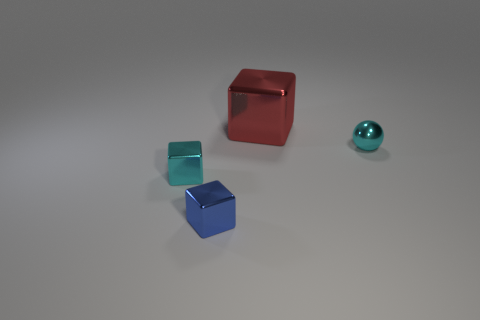There is a big shiny object; is its shape the same as the tiny cyan thing that is to the left of the large red block?
Offer a terse response. Yes. There is a small object that is the same color as the ball; what material is it?
Ensure brevity in your answer.  Metal. Is there any other thing that is the same shape as the big shiny object?
Offer a terse response. Yes. Do the cyan cube and the thing that is behind the tiny cyan metal sphere have the same material?
Keep it short and to the point. Yes. What is the color of the block that is in front of the cyan object left of the small thing that is right of the red shiny thing?
Ensure brevity in your answer.  Blue. Is there anything else that is the same size as the red thing?
Provide a short and direct response. No. Do the shiny ball and the block that is behind the cyan sphere have the same color?
Your answer should be compact. No. The small metallic ball is what color?
Keep it short and to the point. Cyan. The tiny shiny object right of the tiny cube right of the small cyan object that is on the left side of the red shiny object is what shape?
Make the answer very short. Sphere. How many other objects are the same color as the tiny shiny ball?
Your answer should be very brief. 1. 